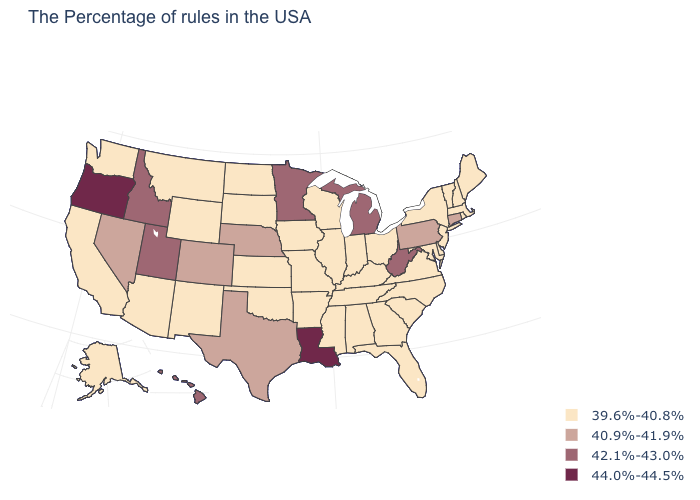What is the value of Pennsylvania?
Be succinct. 40.9%-41.9%. What is the highest value in the USA?
Write a very short answer. 44.0%-44.5%. Is the legend a continuous bar?
Short answer required. No. What is the value of Texas?
Be succinct. 40.9%-41.9%. Name the states that have a value in the range 42.1%-43.0%?
Answer briefly. West Virginia, Michigan, Minnesota, Utah, Idaho, Hawaii. Is the legend a continuous bar?
Quick response, please. No. Name the states that have a value in the range 39.6%-40.8%?
Quick response, please. Maine, Massachusetts, Rhode Island, New Hampshire, Vermont, New York, New Jersey, Delaware, Maryland, Virginia, North Carolina, South Carolina, Ohio, Florida, Georgia, Kentucky, Indiana, Alabama, Tennessee, Wisconsin, Illinois, Mississippi, Missouri, Arkansas, Iowa, Kansas, Oklahoma, South Dakota, North Dakota, Wyoming, New Mexico, Montana, Arizona, California, Washington, Alaska. What is the lowest value in the USA?
Concise answer only. 39.6%-40.8%. What is the value of Idaho?
Be succinct. 42.1%-43.0%. Does New York have the lowest value in the USA?
Concise answer only. Yes. What is the value of Wisconsin?
Concise answer only. 39.6%-40.8%. Name the states that have a value in the range 40.9%-41.9%?
Short answer required. Connecticut, Pennsylvania, Nebraska, Texas, Colorado, Nevada. What is the lowest value in the USA?
Answer briefly. 39.6%-40.8%. Which states have the lowest value in the MidWest?
Concise answer only. Ohio, Indiana, Wisconsin, Illinois, Missouri, Iowa, Kansas, South Dakota, North Dakota. 